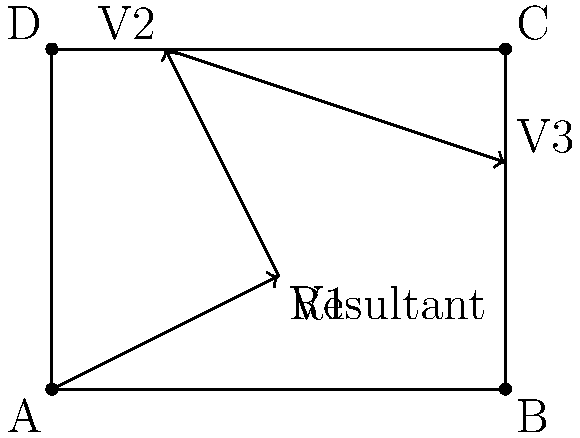In a North Carolina county, three consecutive redistricting changes have occurred over the past decade. These changes can be represented by vectors $\vec{V1} = (2,1)$, $\vec{V2} = (-1,2)$, and $\vec{V3} = (3,-1)$, where each unit represents 1 mile. If these changes are applied sequentially, what is the resultant vector that represents the total shift in the district's center from its original position? To find the resultant vector when combining multiple redistricting changes, we need to add the given vectors together. Let's approach this step-by-step:

1. We have three vectors:
   $\vec{V1} = (2,1)$
   $\vec{V2} = (-1,2)$
   $\vec{V3} = (3,-1)$

2. To find the resultant vector $\vec{R}$, we add these vectors:
   $\vec{R} = \vec{V1} + \vec{V2} + \vec{V3}$

3. Adding vectors means adding their corresponding components:
   $\vec{R} = (2,1) + (-1,2) + (3,-1)$

4. Let's add the x-components:
   $R_x = 2 + (-1) + 3 = 4$

5. Now, let's add the y-components:
   $R_y = 1 + 2 + (-1) = 2$

6. Therefore, the resultant vector is:
   $\vec{R} = (4,2)$

This vector represents the total shift of the district's center, 4 miles east and 2 miles north from its original position.
Answer: $(4,2)$ 